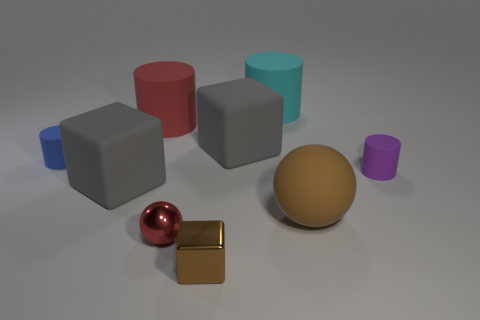There is a small metallic sphere; is it the same color as the large cylinder in front of the big cyan matte cylinder?
Your answer should be very brief. Yes. There is a cyan thing that is made of the same material as the brown sphere; what size is it?
Make the answer very short. Large. There is a thing that is the same color as the tiny cube; what size is it?
Your answer should be compact. Large. Is the large ball the same color as the metallic block?
Ensure brevity in your answer.  Yes. Are there any gray objects that are in front of the small cylinder that is to the left of the brown object that is behind the metal cube?
Provide a short and direct response. Yes. What number of purple cylinders are the same size as the cyan thing?
Your answer should be compact. 0. There is a gray block in front of the blue object; is its size the same as the metal thing behind the tiny metallic block?
Give a very brief answer. No. There is a small object that is to the left of the tiny cube and to the right of the tiny blue matte object; what shape is it?
Offer a very short reply. Sphere. Are there any other rubber balls that have the same color as the large rubber ball?
Keep it short and to the point. No. Is there a tiny green metallic cube?
Make the answer very short. No. 